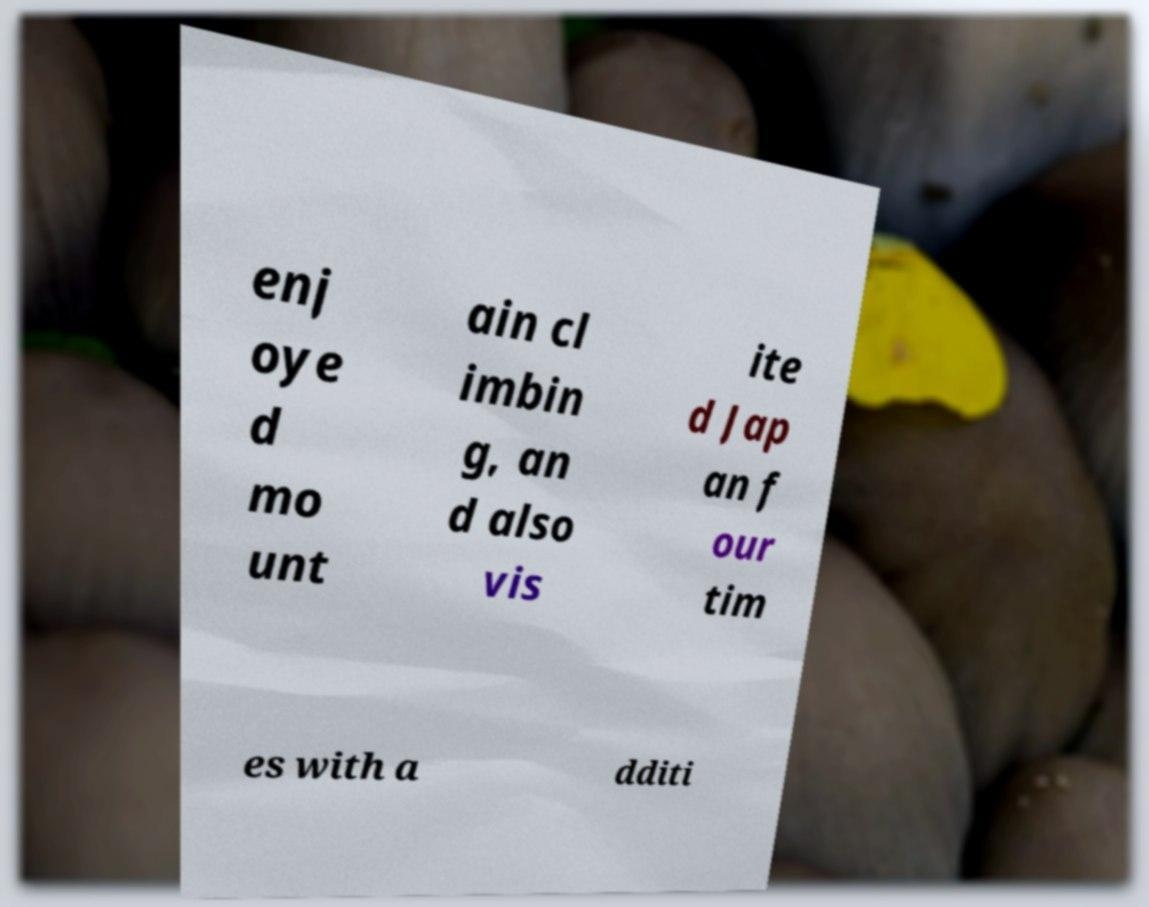Could you assist in decoding the text presented in this image and type it out clearly? enj oye d mo unt ain cl imbin g, an d also vis ite d Jap an f our tim es with a dditi 